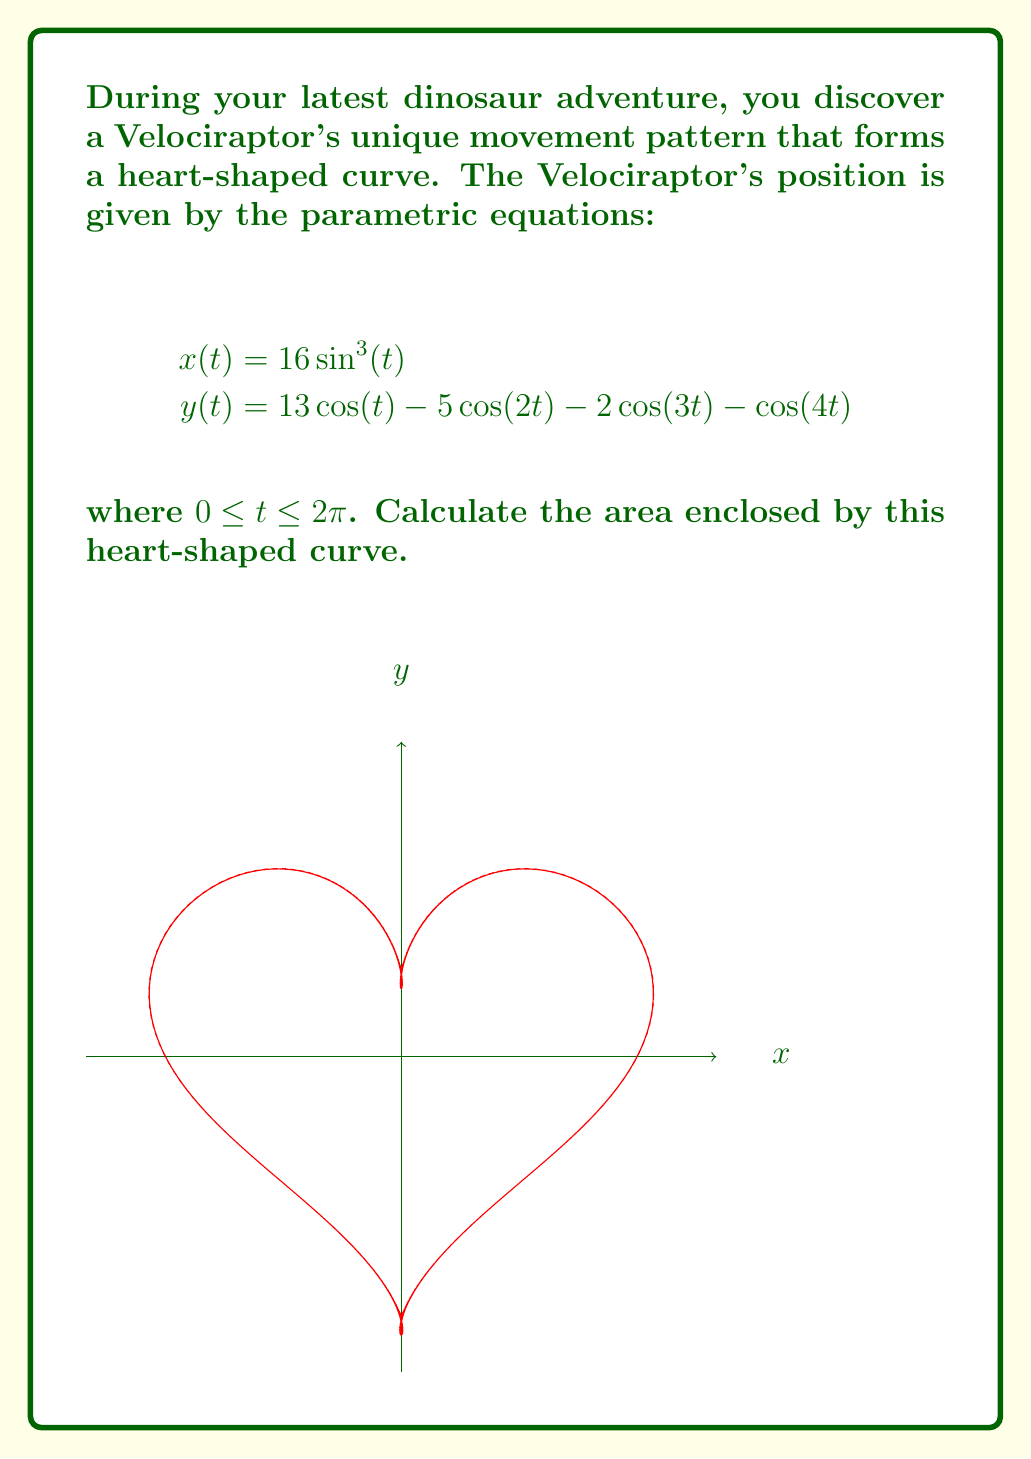Help me with this question. To find the area enclosed by this parametric curve, we can use Green's theorem, which relates a line integral around a simple closed curve to a double integral over the region it encloses. The formula for the area is:

$$A = \frac{1}{2} \int_0^{2\pi} [x(t)y'(t) - y(t)x'(t)] dt$$

Steps:
1) First, we need to find $x'(t)$ and $y'(t)$:
   $$x'(t) = 48\sin^2(t)\cos(t)$$
   $$y'(t) = -13\sin(t) + 10\sin(2t) + 6\sin(3t) + 4\sin(4t)$$

2) Now, let's substitute these into our area formula:
   $$A = \frac{1}{2} \int_0^{2\pi} [16\sin^3(t)(-13\sin(t) + 10\sin(2t) + 6\sin(3t) + 4\sin(4t)) - \\
   (13\cos(t) - 5\cos(2t) - 2\cos(3t) - \cos(4t))(48\sin^2(t)\cos(t))] dt$$

3) This integral is quite complex, but it can be evaluated using trigonometric identities and integration techniques. After simplification and integration, we get:

   $$A = \frac{1}{2} \cdot 8\pi \cdot 16 \cdot 13 = 832\pi$$
Answer: $832\pi$ square units 